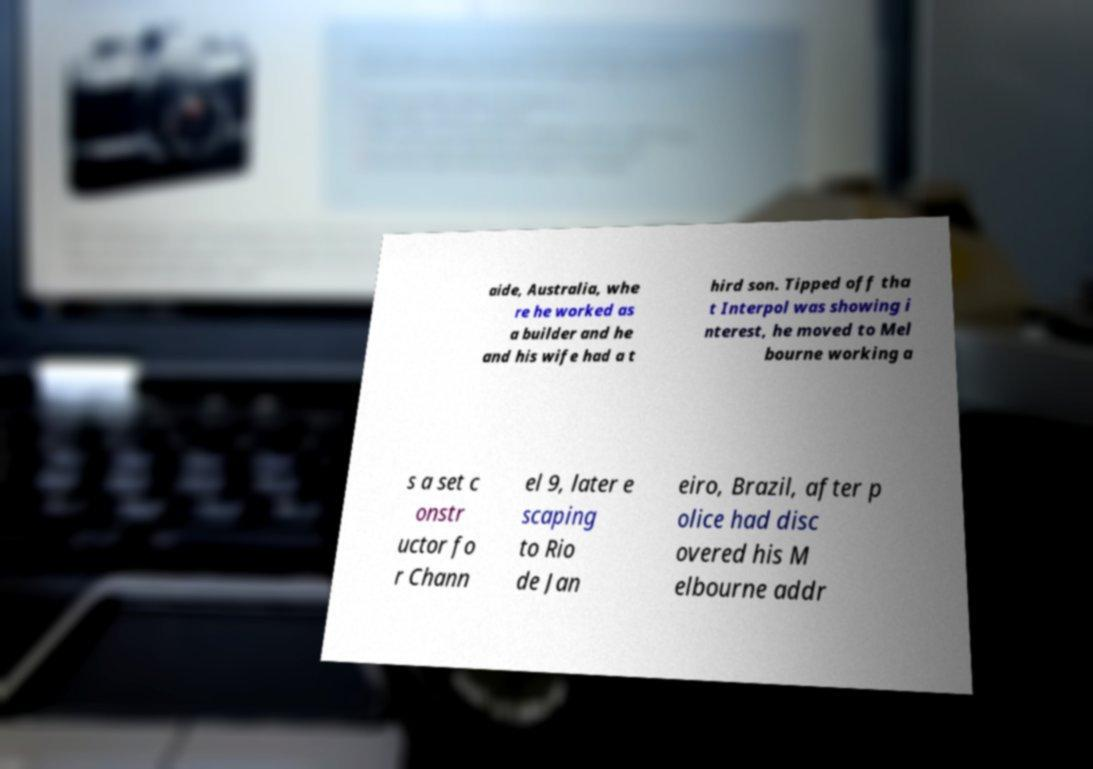For documentation purposes, I need the text within this image transcribed. Could you provide that? aide, Australia, whe re he worked as a builder and he and his wife had a t hird son. Tipped off tha t Interpol was showing i nterest, he moved to Mel bourne working a s a set c onstr uctor fo r Chann el 9, later e scaping to Rio de Jan eiro, Brazil, after p olice had disc overed his M elbourne addr 